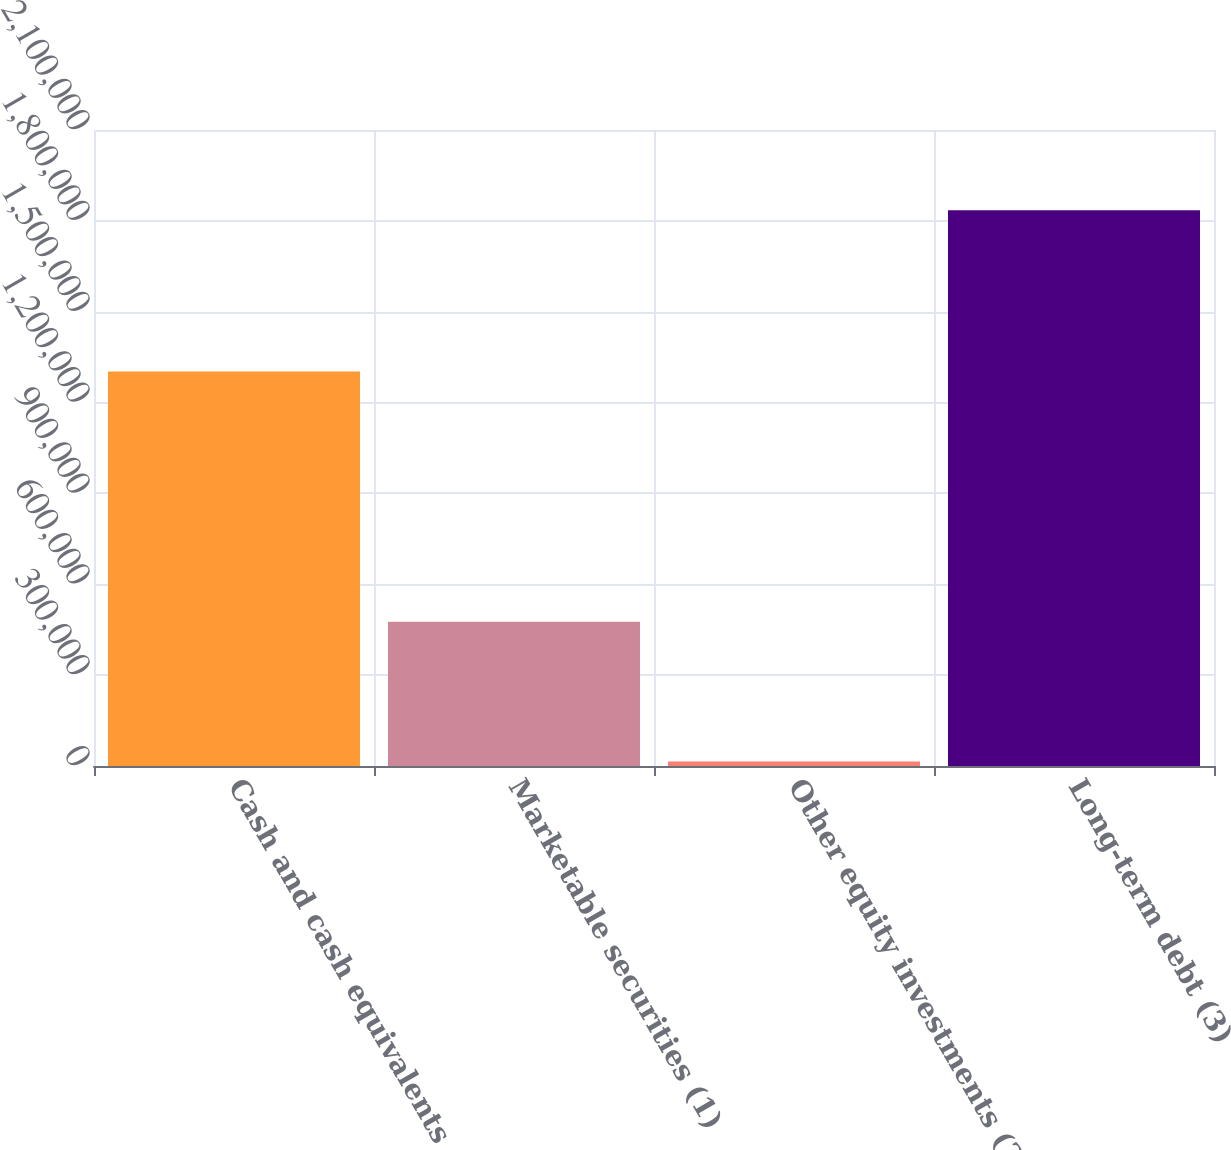<chart> <loc_0><loc_0><loc_500><loc_500><bar_chart><fcel>Cash and cash equivalents<fcel>Marketable securities (1)<fcel>Other equity investments (2)<fcel>Long-term debt (3)<nl><fcel>1.3026e+06<fcel>476599<fcel>15018<fcel>1.83485e+06<nl></chart> 